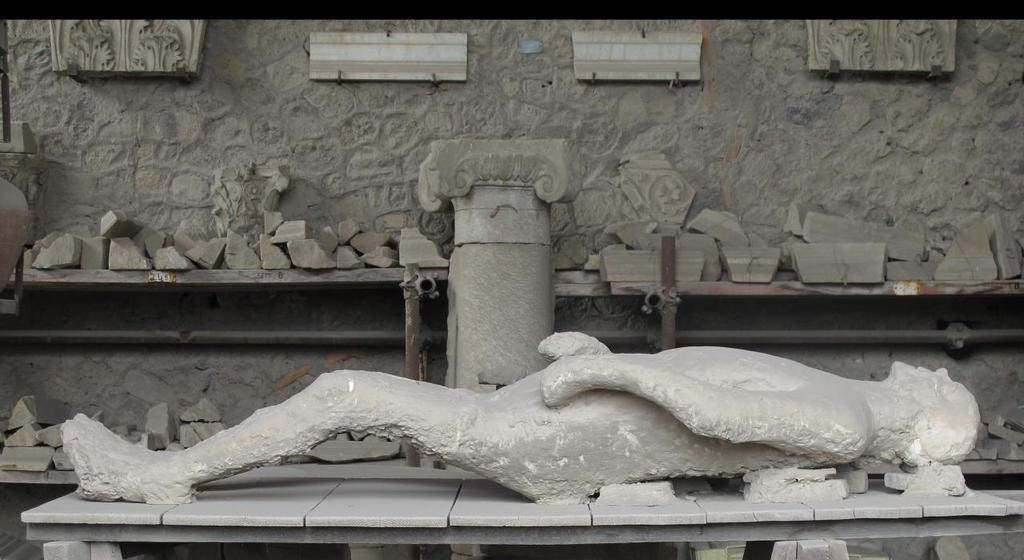What is the main subject of the image? There is a carved stone in the shape of a human being in the image. What can be seen in the background of the image? There are stones and a wall in the background of the image. What type of bone is visible in the image? There is no bone present in the image; it features a carved stone in the shape of a human being. How does the poison affect the carved stone in the image? There is no poison present in the image, as it features a carved stone and not a living organism. 